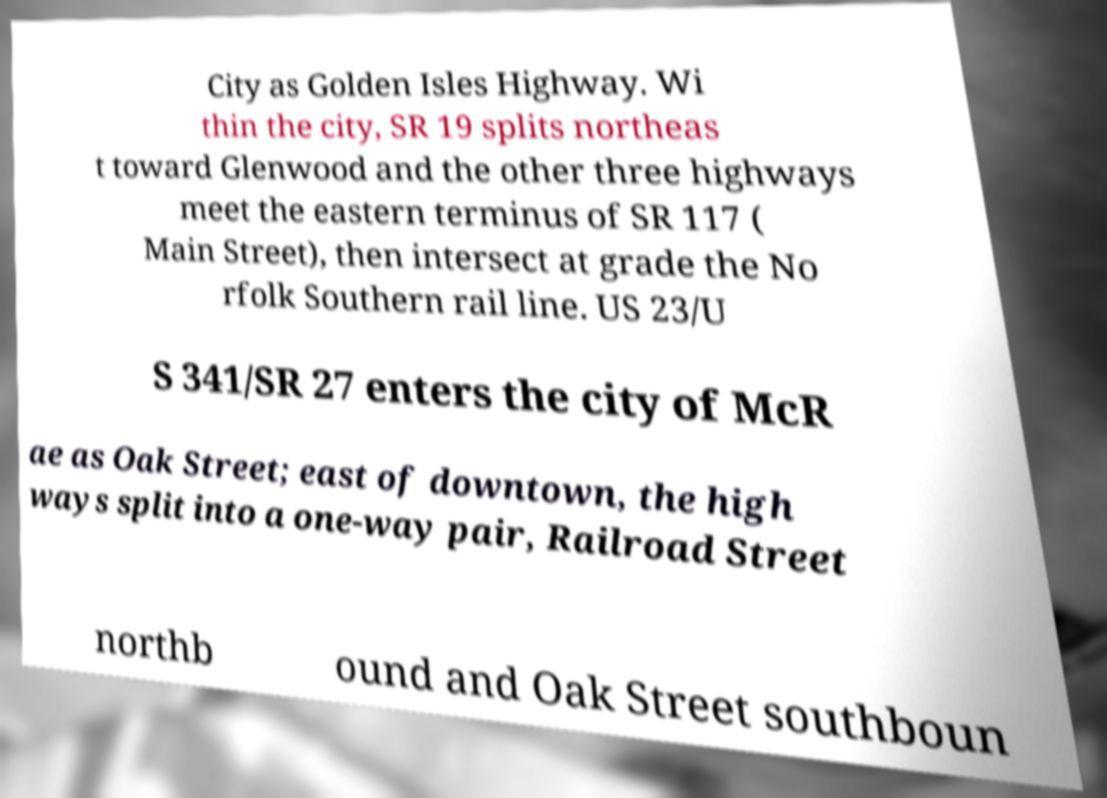There's text embedded in this image that I need extracted. Can you transcribe it verbatim? City as Golden Isles Highway. Wi thin the city, SR 19 splits northeas t toward Glenwood and the other three highways meet the eastern terminus of SR 117 ( Main Street), then intersect at grade the No rfolk Southern rail line. US 23/U S 341/SR 27 enters the city of McR ae as Oak Street; east of downtown, the high ways split into a one-way pair, Railroad Street northb ound and Oak Street southboun 